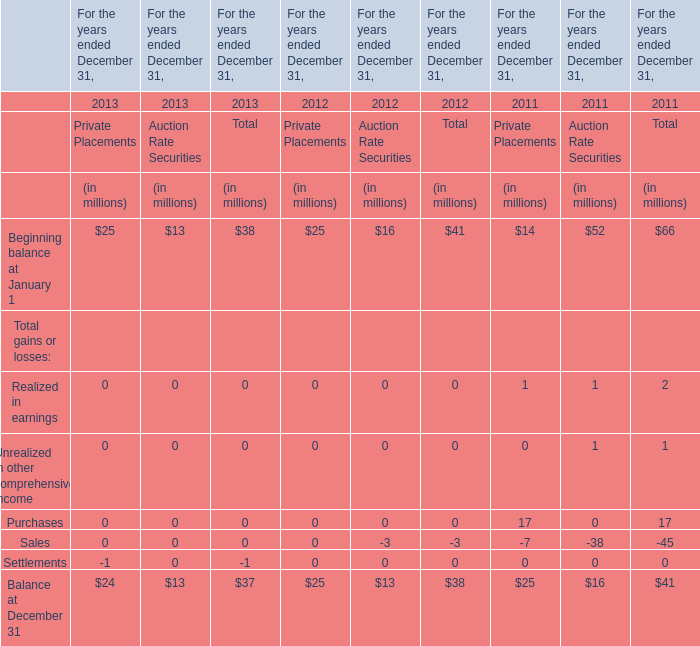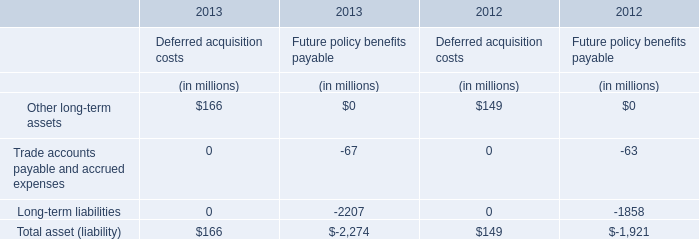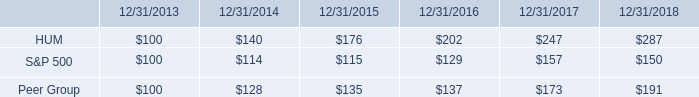What's the sum of the Beginning balance at January 1 for Private Placements in the years where Other long-term assets for Deferred acquisition costs is positive? (in million) 
Computations: (25 + 25)
Answer: 50.0. 